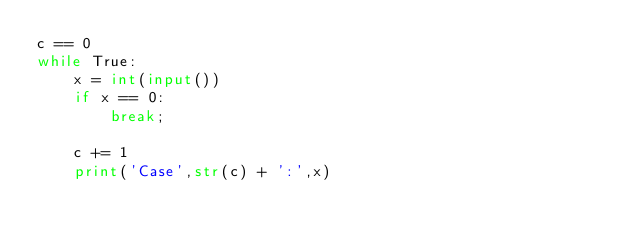Convert code to text. <code><loc_0><loc_0><loc_500><loc_500><_Python_>c == 0
while True:
    x = int(input())
    if x == 0:
        break;
   
    c += 1
    print('Case',str(c) + ':',x)</code> 